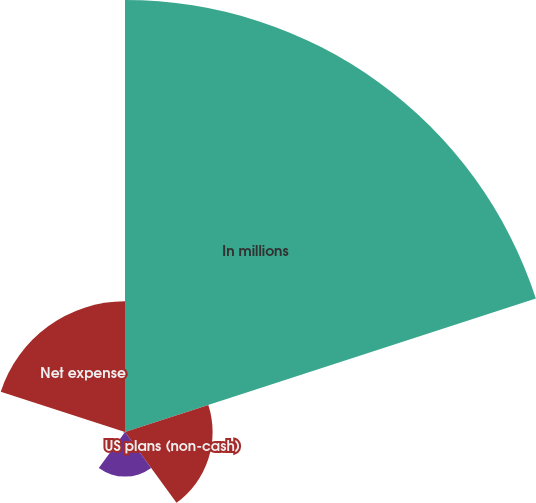<chart> <loc_0><loc_0><loc_500><loc_500><pie_chart><fcel>In millions<fcel>US plans (non-cash)<fcel>Non-US plans<fcel>US plans<fcel>Net expense<nl><fcel>62.04%<fcel>12.58%<fcel>6.4%<fcel>0.22%<fcel>18.76%<nl></chart> 